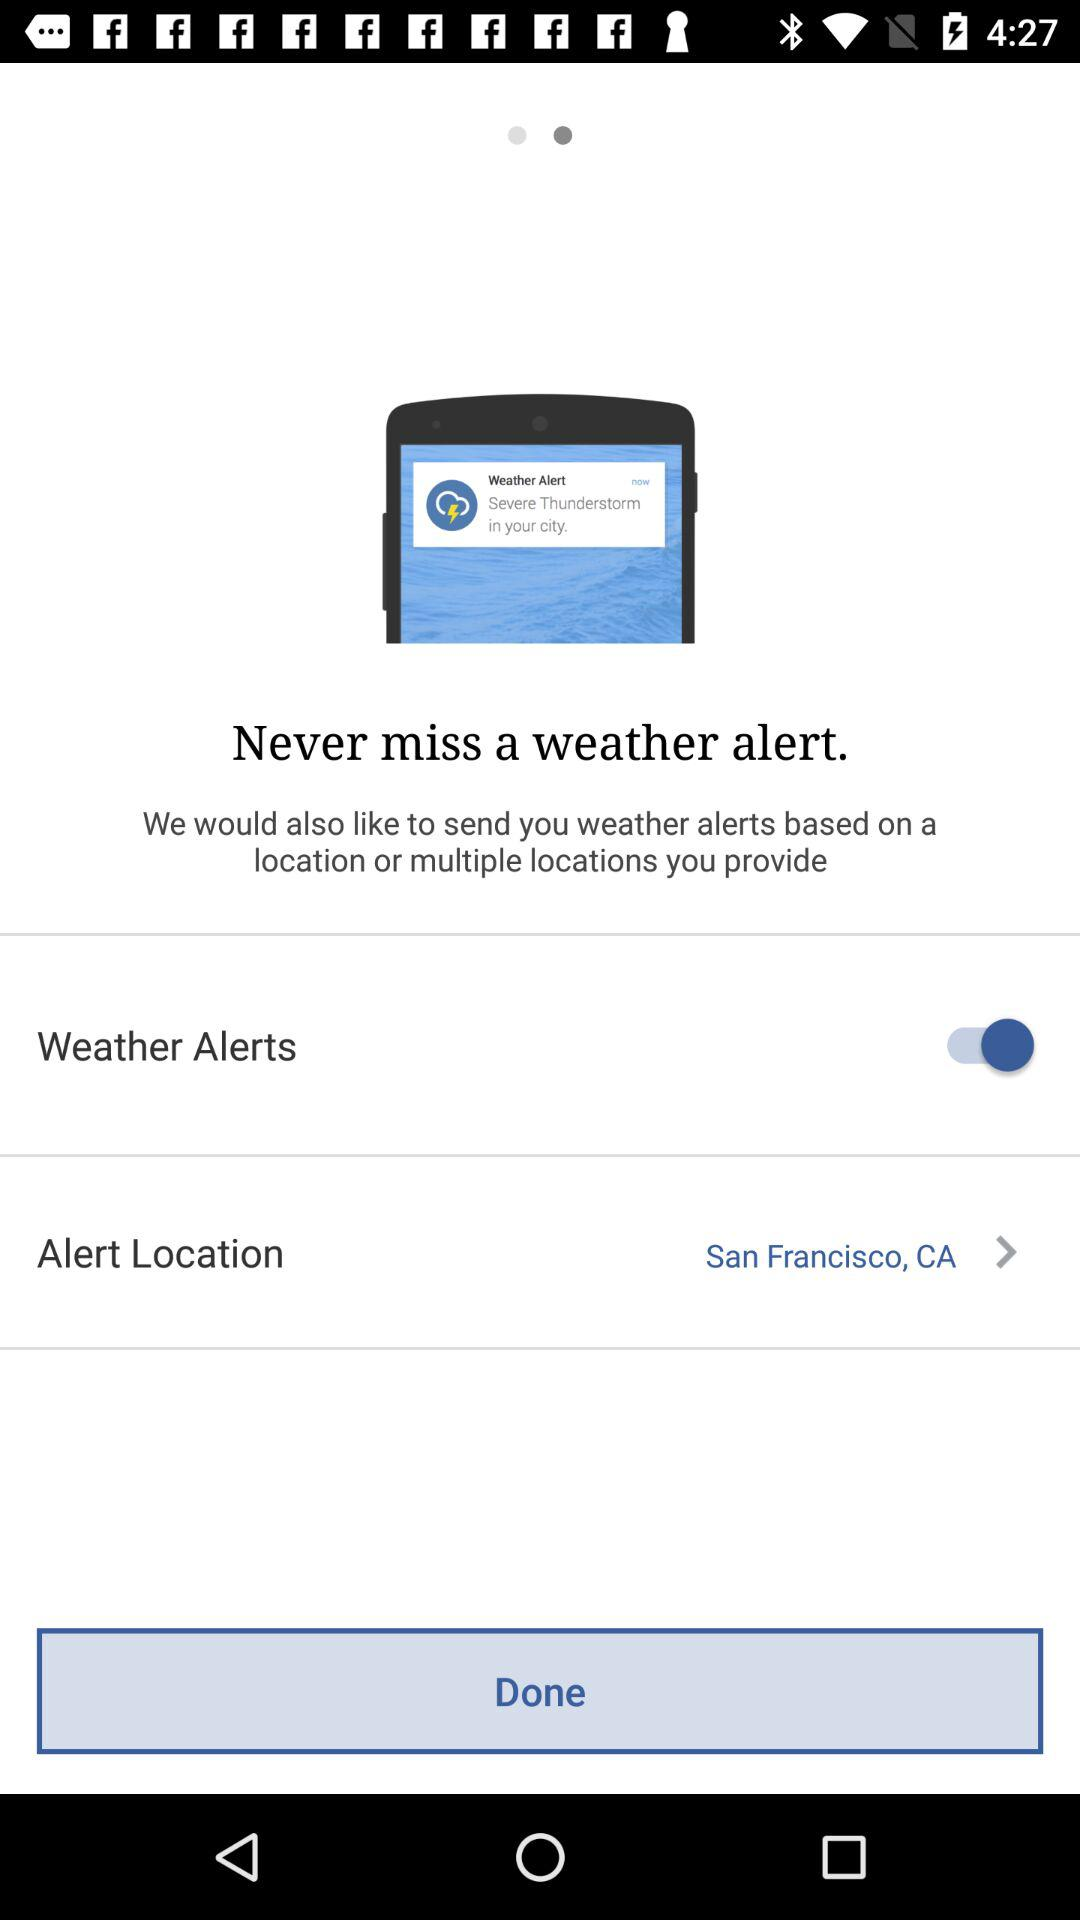What option is selected for "Alert Location"? The selected option is "San Francisco, CA". 